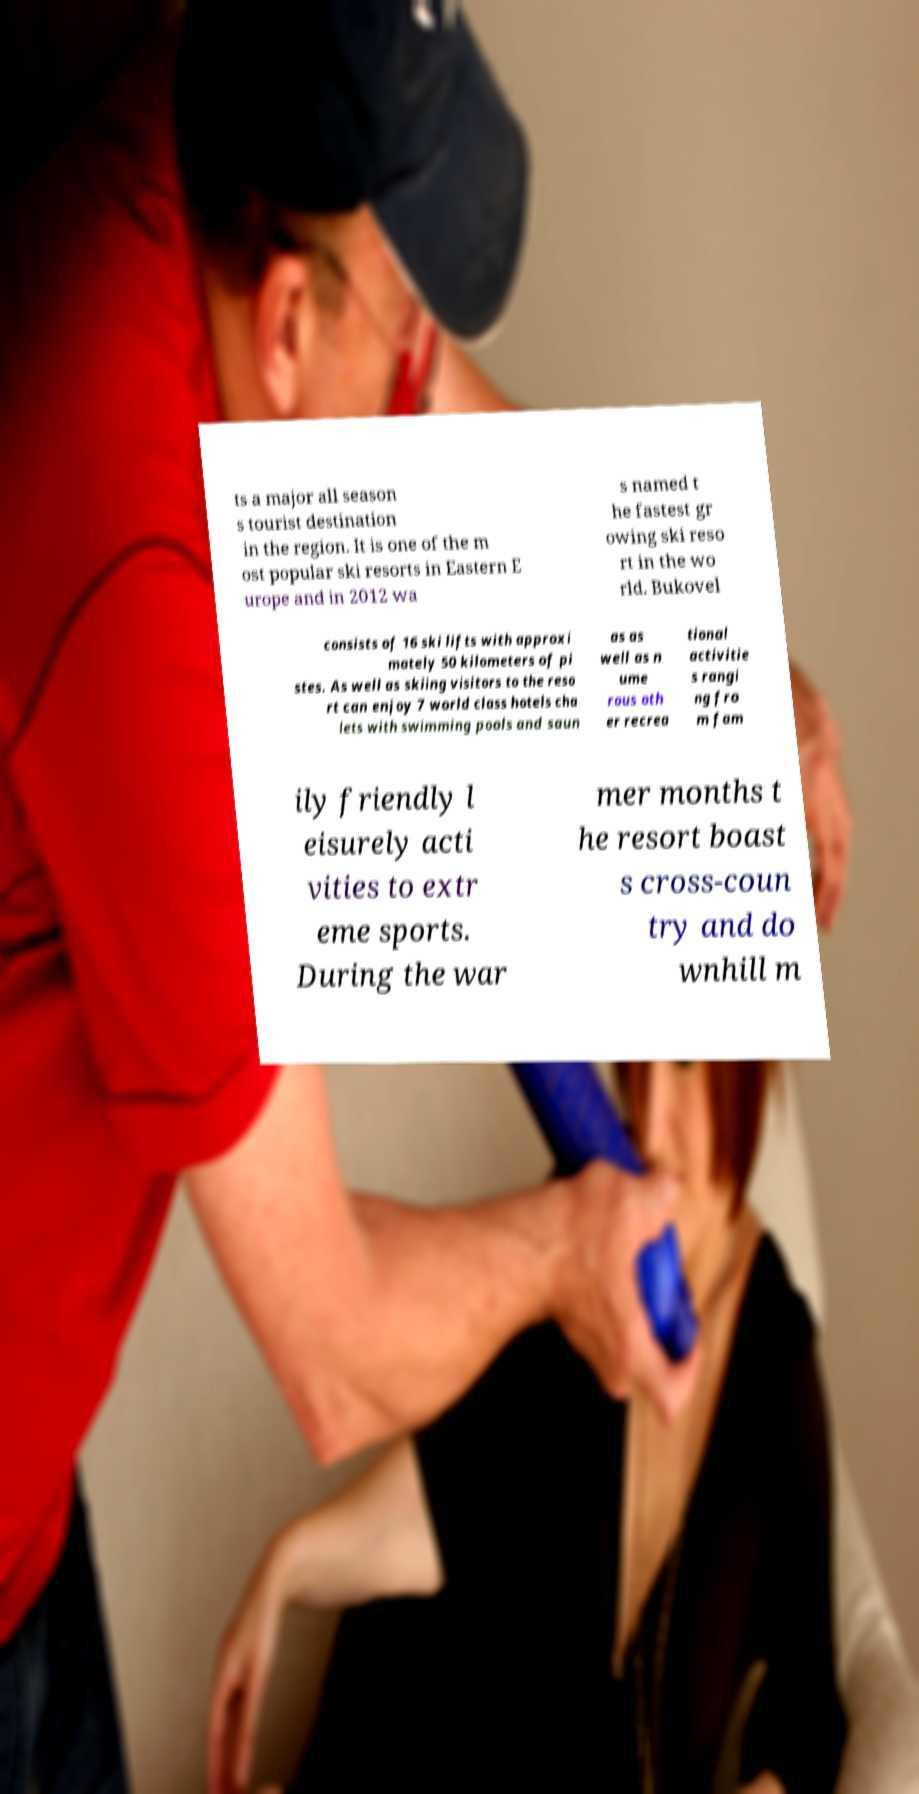Could you extract and type out the text from this image? ts a major all season s tourist destination in the region. It is one of the m ost popular ski resorts in Eastern E urope and in 2012 wa s named t he fastest gr owing ski reso rt in the wo rld. Bukovel consists of 16 ski lifts with approxi mately 50 kilometers of pi stes. As well as skiing visitors to the reso rt can enjoy 7 world class hotels cha lets with swimming pools and saun as as well as n ume rous oth er recrea tional activitie s rangi ng fro m fam ily friendly l eisurely acti vities to extr eme sports. During the war mer months t he resort boast s cross-coun try and do wnhill m 